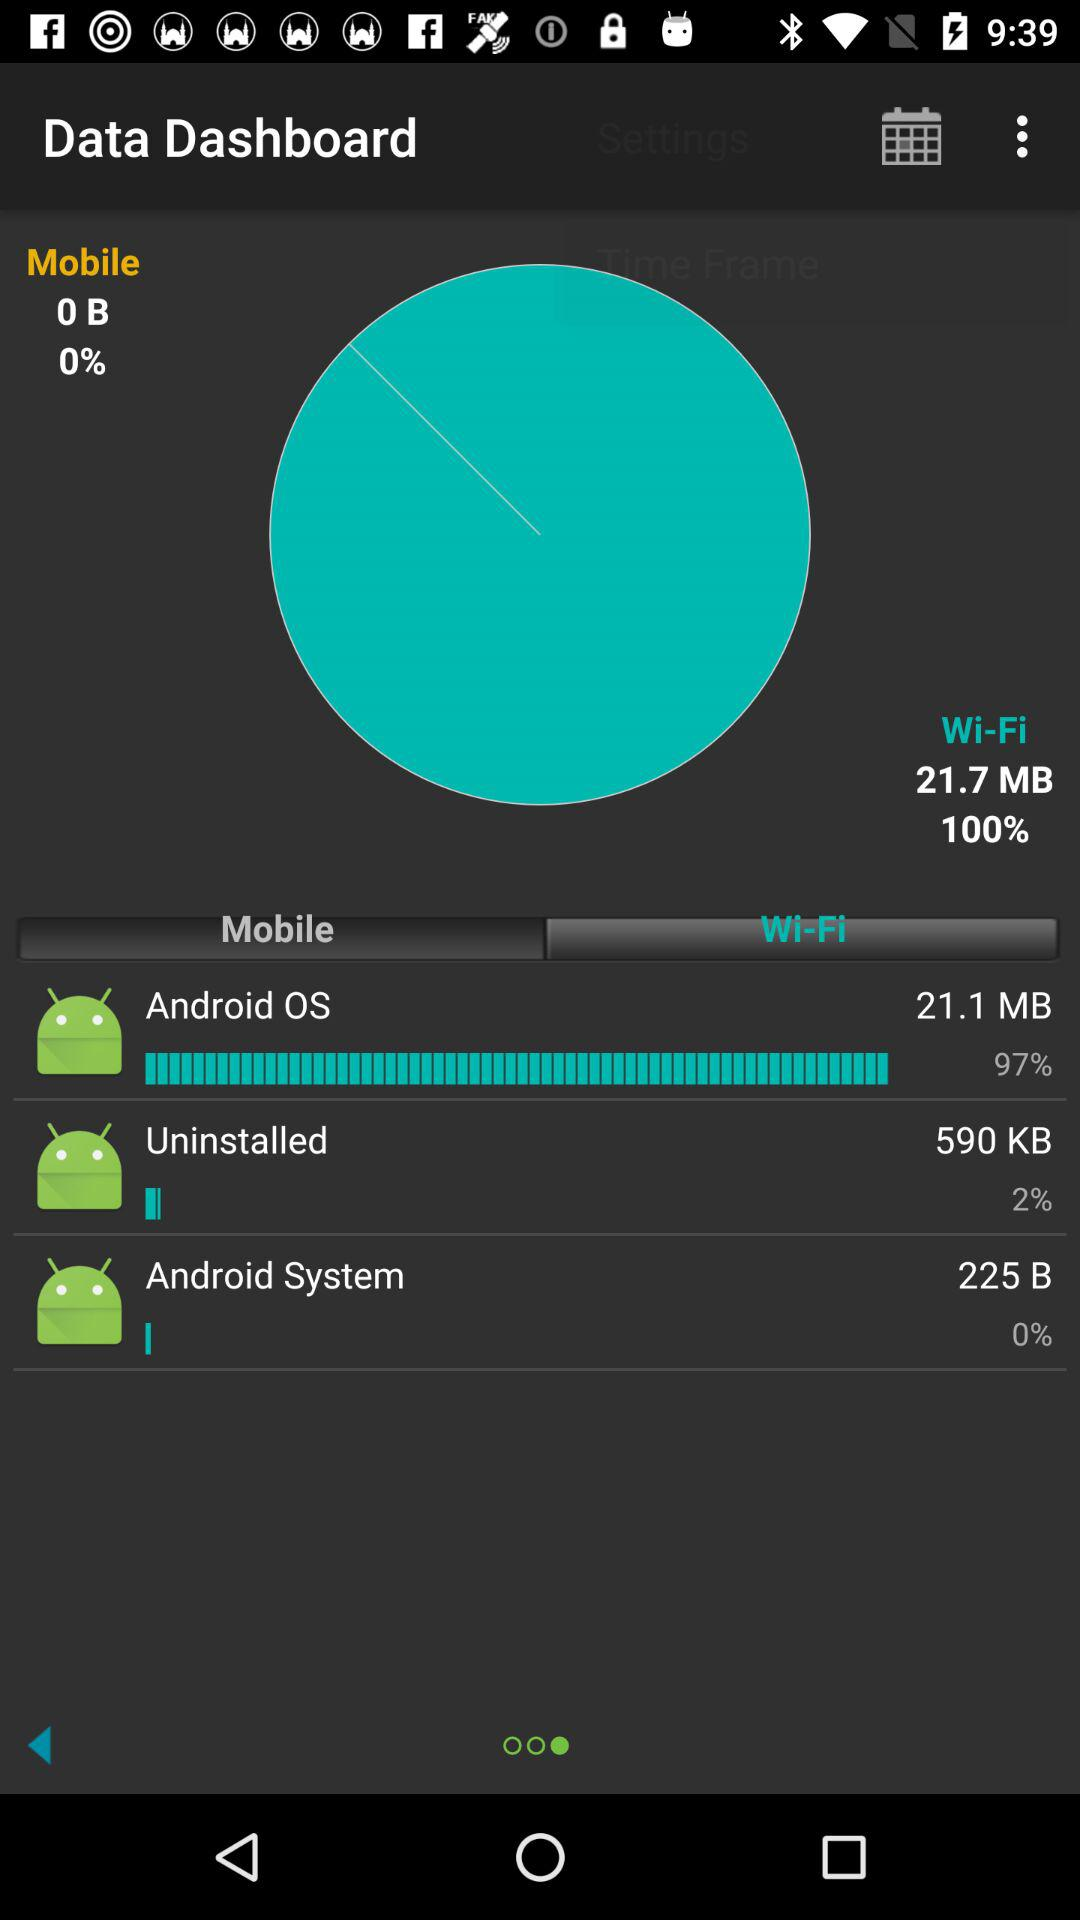How much data is consumed by the Android system over WiFi in bytes? Over WiFi, the Android system has consumed 225 bytes of data. 